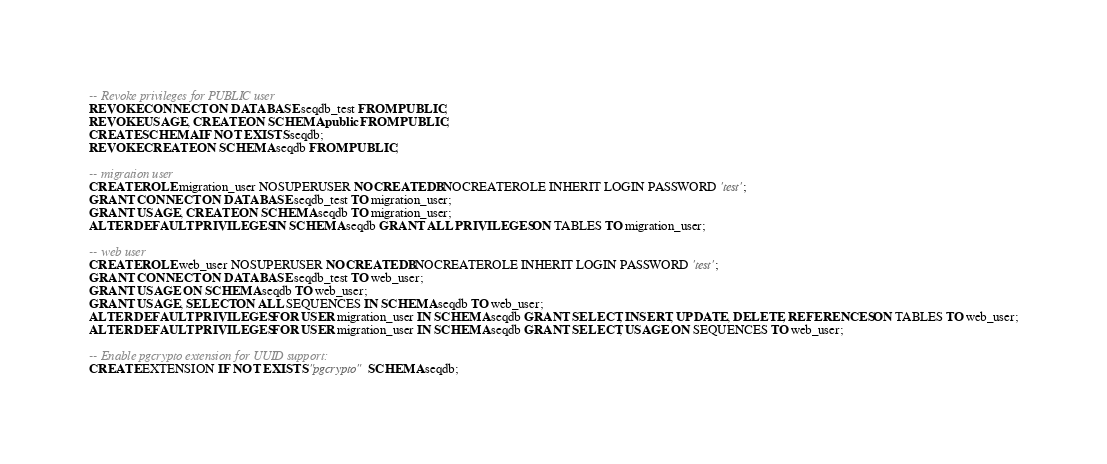<code> <loc_0><loc_0><loc_500><loc_500><_SQL_>-- Revoke privileges for PUBLIC user
REVOKE CONNECT ON DATABASE seqdb_test FROM PUBLIC;
REVOKE USAGE, CREATE ON SCHEMA public FROM PUBLIC;
CREATE SCHEMA IF NOT EXISTS seqdb;
REVOKE CREATE ON SCHEMA seqdb FROM PUBLIC;

-- migration user
CREATE ROLE migration_user NOSUPERUSER NOCREATEDB NOCREATEROLE INHERIT LOGIN PASSWORD 'test';
GRANT CONNECT ON DATABASE seqdb_test TO migration_user;
GRANT USAGE, CREATE ON SCHEMA seqdb TO migration_user;
ALTER DEFAULT PRIVILEGES IN SCHEMA seqdb GRANT ALL PRIVILEGES ON TABLES TO migration_user;

-- web user
CREATE ROLE web_user NOSUPERUSER NOCREATEDB NOCREATEROLE INHERIT LOGIN PASSWORD 'test';
GRANT CONNECT ON DATABASE seqdb_test TO web_user;
GRANT USAGE ON SCHEMA seqdb TO web_user;
GRANT USAGE, SELECT ON ALL SEQUENCES IN SCHEMA seqdb TO web_user;
ALTER DEFAULT PRIVILEGES FOR USER migration_user IN SCHEMA seqdb GRANT SELECT, INSERT, UPDATE, DELETE, REFERENCES ON TABLES TO web_user;
ALTER DEFAULT PRIVILEGES FOR USER migration_user IN SCHEMA seqdb GRANT SELECT, USAGE ON SEQUENCES TO web_user;

-- Enable pgcrypto extension for UUID support:
CREATE EXTENSION IF NOT EXISTS "pgcrypto" SCHEMA seqdb;
</code> 